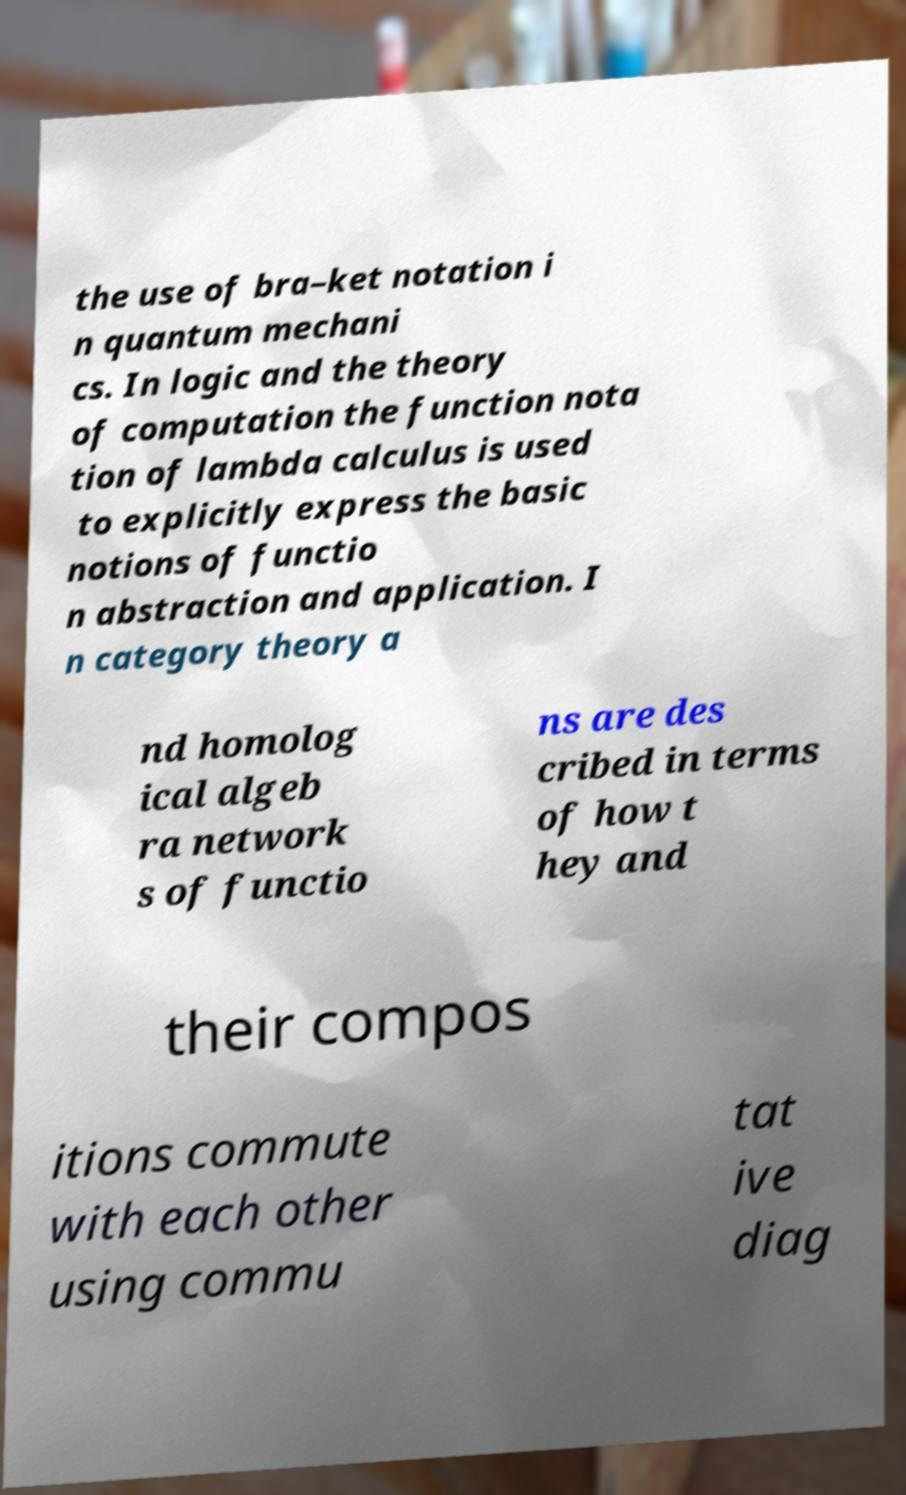Can you read and provide the text displayed in the image?This photo seems to have some interesting text. Can you extract and type it out for me? the use of bra–ket notation i n quantum mechani cs. In logic and the theory of computation the function nota tion of lambda calculus is used to explicitly express the basic notions of functio n abstraction and application. I n category theory a nd homolog ical algeb ra network s of functio ns are des cribed in terms of how t hey and their compos itions commute with each other using commu tat ive diag 